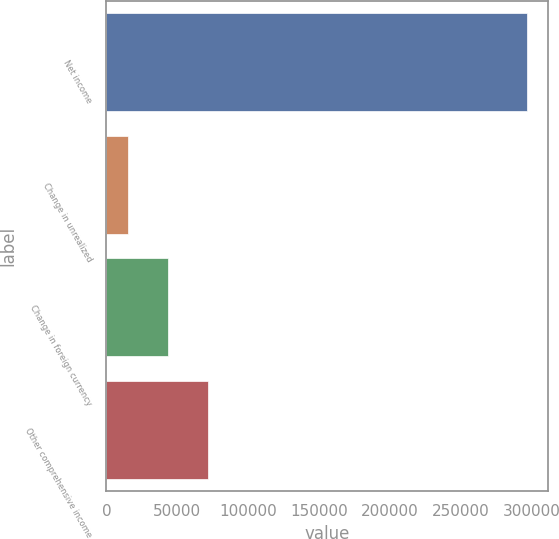<chart> <loc_0><loc_0><loc_500><loc_500><bar_chart><fcel>Net income<fcel>Change in unrealized<fcel>Change in foreign currency<fcel>Other comprehensive income<nl><fcel>297137<fcel>15102<fcel>43305.5<fcel>71509<nl></chart> 